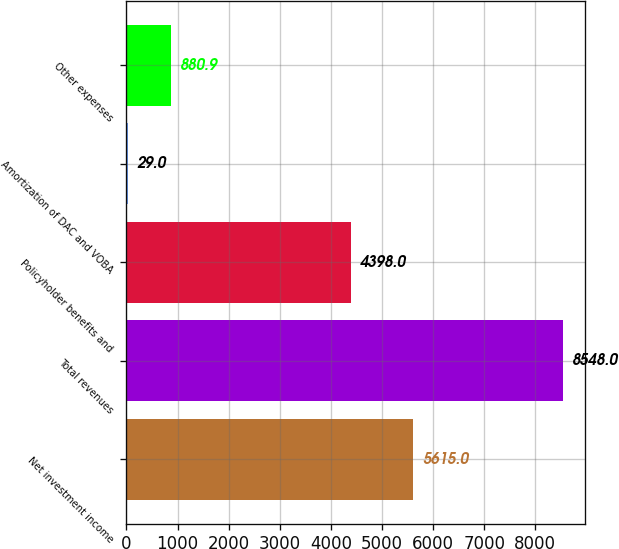<chart> <loc_0><loc_0><loc_500><loc_500><bar_chart><fcel>Net investment income<fcel>Total revenues<fcel>Policyholder benefits and<fcel>Amortization of DAC and VOBA<fcel>Other expenses<nl><fcel>5615<fcel>8548<fcel>4398<fcel>29<fcel>880.9<nl></chart> 